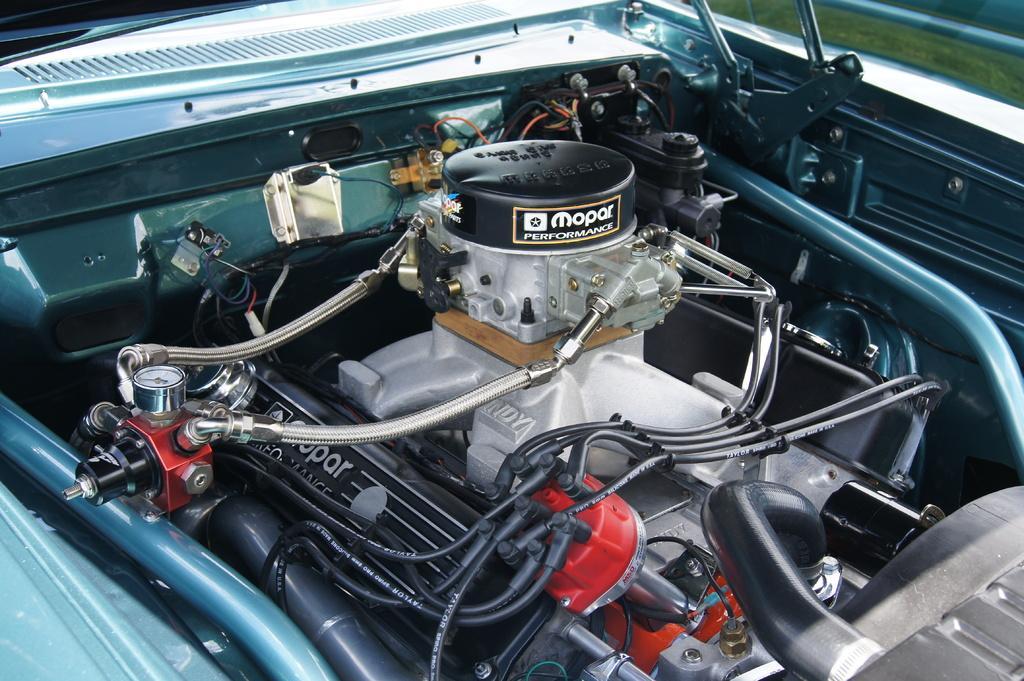In one or two sentences, can you explain what this image depicts? This is the picture of a vehicle. In this image there is a vehicle and there are parts of the vehicle like motor, engine and wires. 